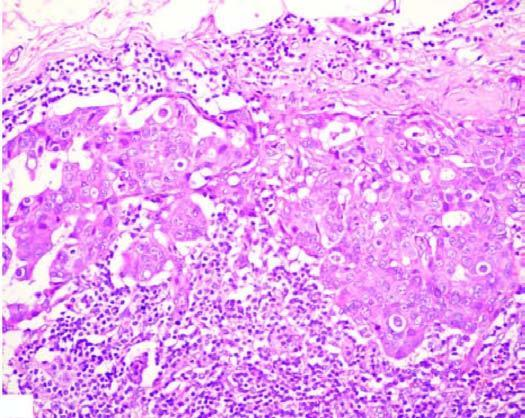s matted mass of lymph nodes surrounded by increased fat?
Answer the question using a single word or phrase. Yes 